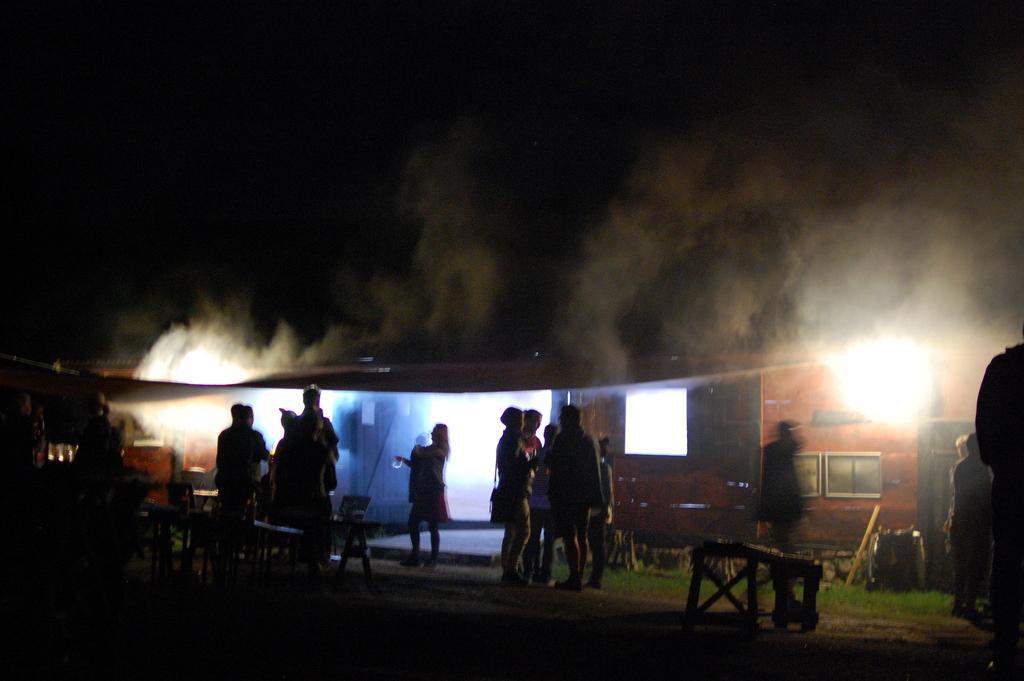Could you give a brief overview of what you see in this image? In this image, I can see the tables, groups of people standing and few other objects. It looks like a house and smoke. There is a dark background. 